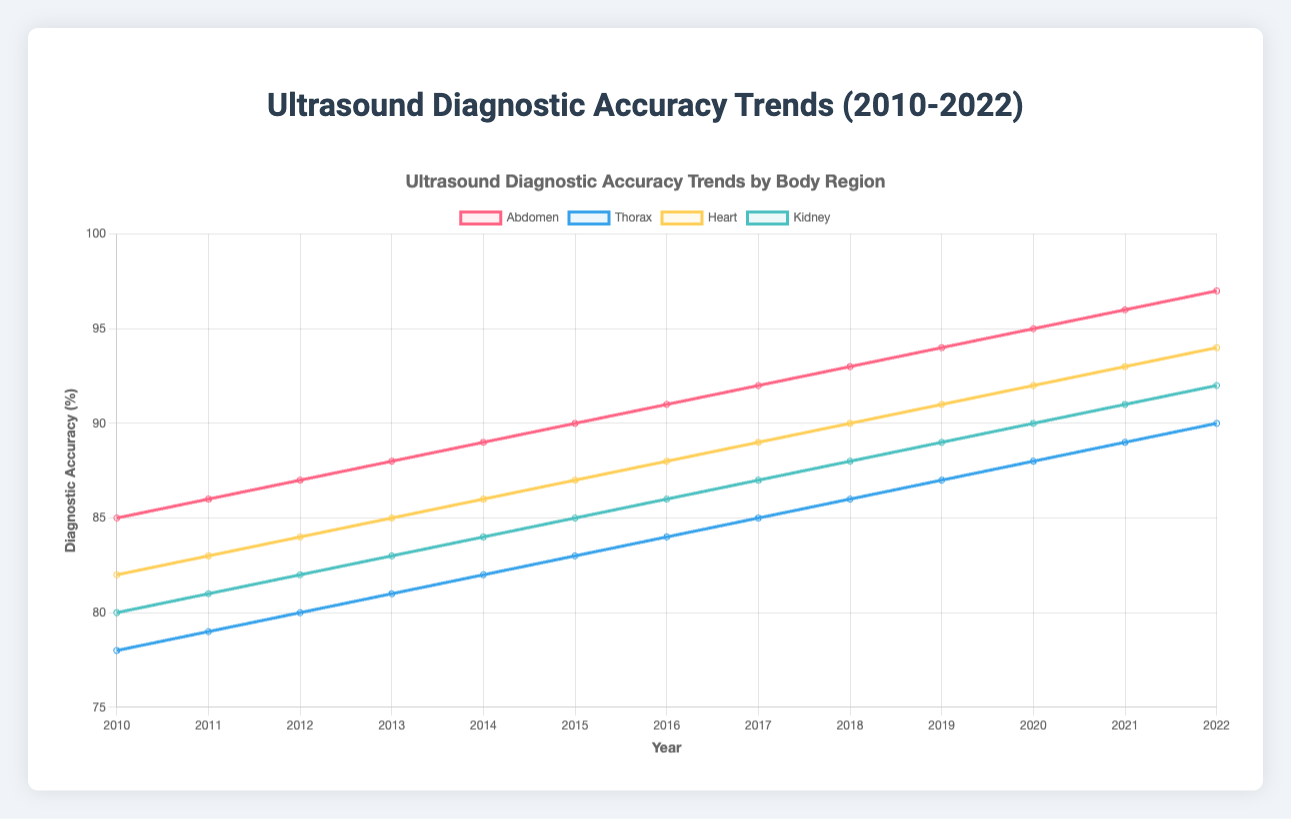What's the trend in diagnostic accuracy for the abdomen? The diagnostic accuracy for the abdomen increases steadily from 85% in 2010 to 97% in 2022.
Answer: Steady increase Which body region had the highest diagnostic accuracy rate in 2022? By looking at the end of the plot lines in 2022, the abdomen, with a diagnostic accuracy of 97%, had the highest rate.
Answer: Abdomen In which year did the thorax and heart achieve the same diagnostic accuracy rate, and what was the rate? Observe where the thorax and heart lines intersect. In 2010, both thorax and heart had diagnostic accuracy rates of 78% and 82%, respectively. In 2021, both reached 89%.
Answer: 2021, 89% By how much did the diagnostic accuracy rate for the kidney improve from 2010 to 2022? Subtract the rate in 2010 from the rate in 2022: 92% - 80% = 12% improvement.
Answer: 12% Over which time period did the heart show the greatest increase in diagnostic accuracy rate? Calculate the differences for each year: 2010-2011, 2011-2012, etc., the highest increase is noticed between 2014 and 2015, with an increase of 1% each year consistently, but the starting base makes this difference important.
Answer: 2014-2015 What’s the average diagnostic accuracy rate for the thorax from 2010 to 2022? Sum all the yearly rates for thorax and divide by the number of years (13): (78 + 79 + 80 + 81 + 82 + 83 + 84 + 85 + 86 + 87 + 88 + 89 + 90) / 13 ≈ 84.
Answer: 84 Which body region had the lowest diagnostic accuracy rate in 2010 and what was the rate? At the starting point of the chart in 2010, the thorax has the lowest rate of 78%.
Answer: Thorax, 78% Compare the diagnostic accuracy rates of the abdomen and kidney in 2015. Which is higher and by how much? Abdomen had 90% and kidney had 85% in 2015. 90% - 85% = 5%.
Answer: Abdomen higher by 5% Which body region consistently saw an increase in diagnostic accuracy rates without any drops from 2010 to 2022? By observing the upward trends for each body region, the abdomen shows a continuous increase with no drops.
Answer: Abdomen How did the diagnostic accuracy for the heart compare to the abdomen in 2020? In 2020, the heart had an accuracy of 92% and the abdomen had 95%. Comparison shows that the abdomen was 3% higher.
Answer: Abdomen higher by 3% 